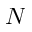Convert formula to latex. <formula><loc_0><loc_0><loc_500><loc_500>N</formula> 